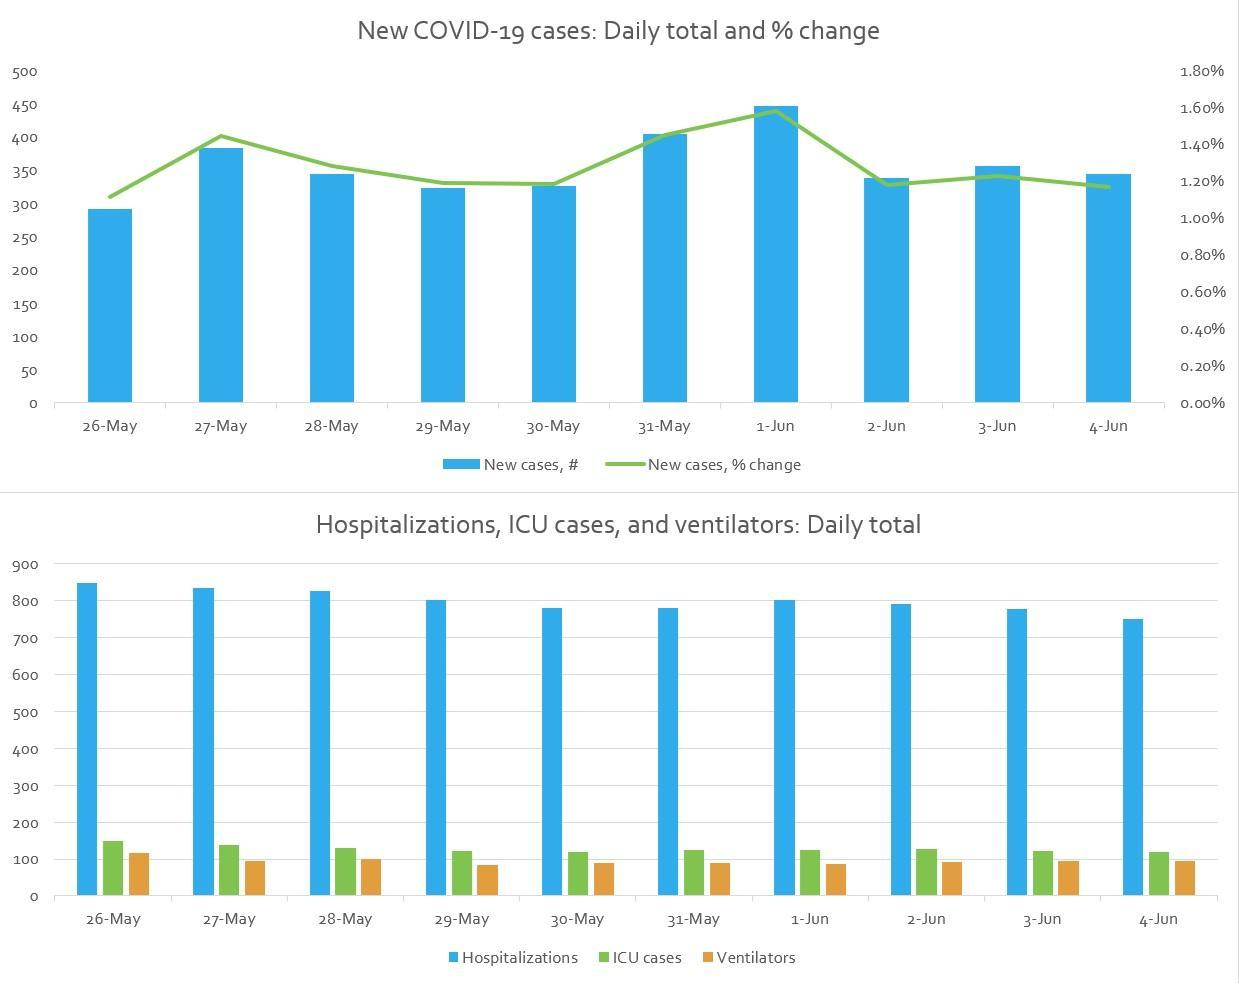statistics of how many days are given in the first bar chart?
Answer the question with a short phrase. 10 statistics of how many days are given in the second bar chart? 10 how many days are there where the number of ICU cases were more than 100? 10 how many days are there where the number of hospitalized cases were more than 700? 10 on which day highest number of new case were reported? 1-Jun In which days the number of hospitalized cases were 800? 29-May, 1-Jun on which day highest number of hospitalization happened? 26-May In which days the number of hospitalized cases were more than 800? 26-May, 27-May, 28-May on which day lowest number of new case were reported? 26-May on which day lowest number of hospitalization happened? 4-Jun In which day the number of ventilators passed 100? 26-May 